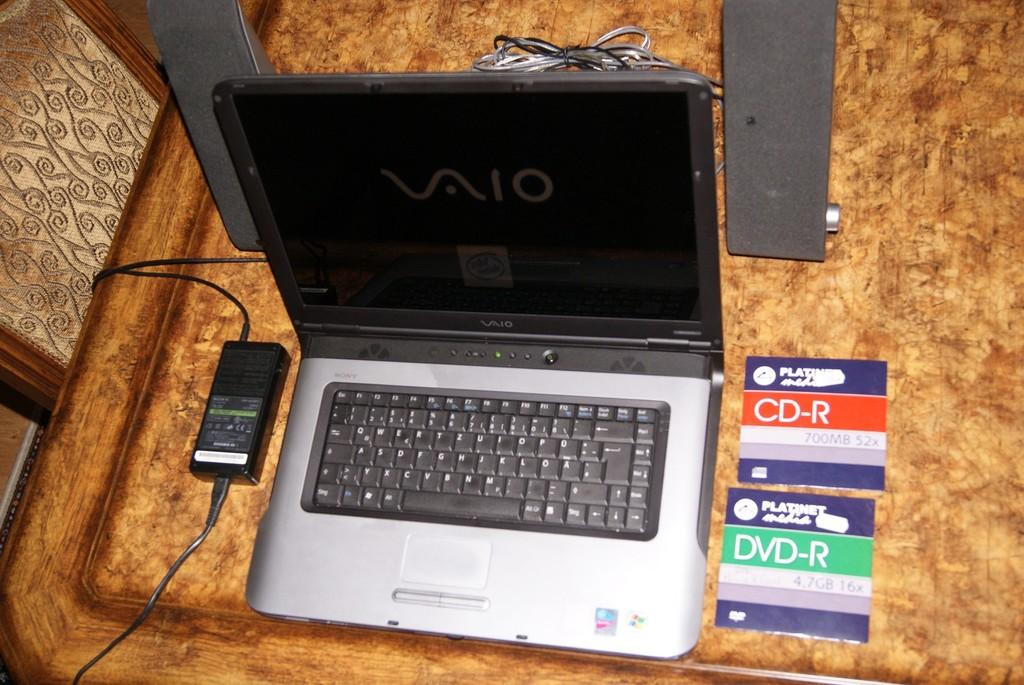<image>
Describe the image concisely. the vaio laptop is open and sitting on the table 